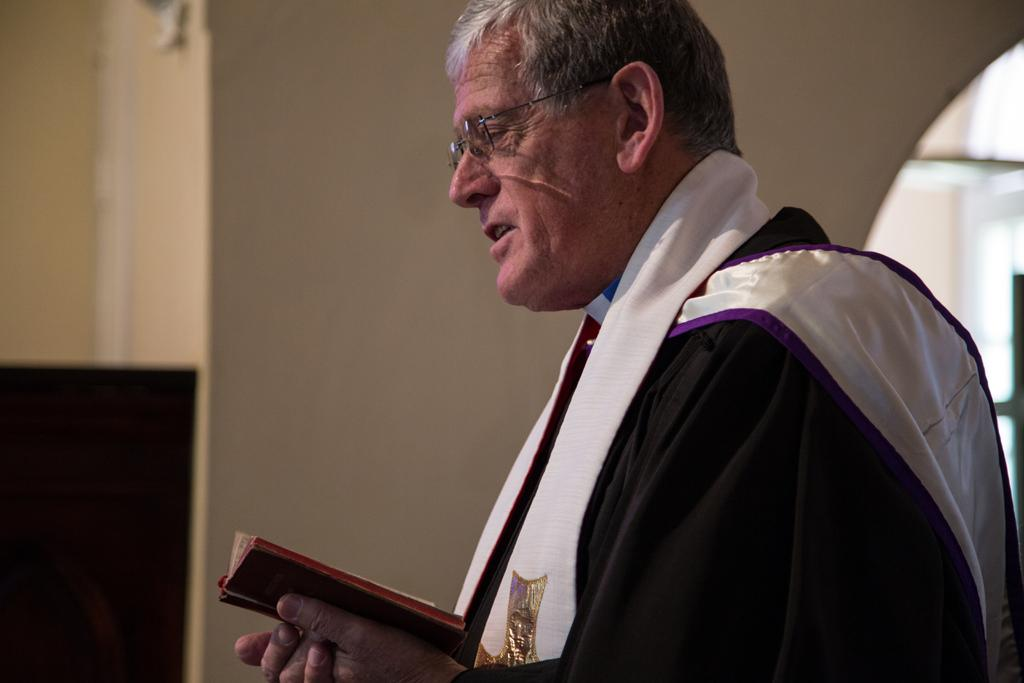Who is present in the image? There is a man in the image. What is the man holding in his hands? The man is holding a book in his hands. What can be seen in the background of the image? There are walls in the background of the image. Why is the man crying while sitting at the desk in the image? There is no mention of the man crying or a desk in the image. The man is holding a book, and there are walls in the background. 